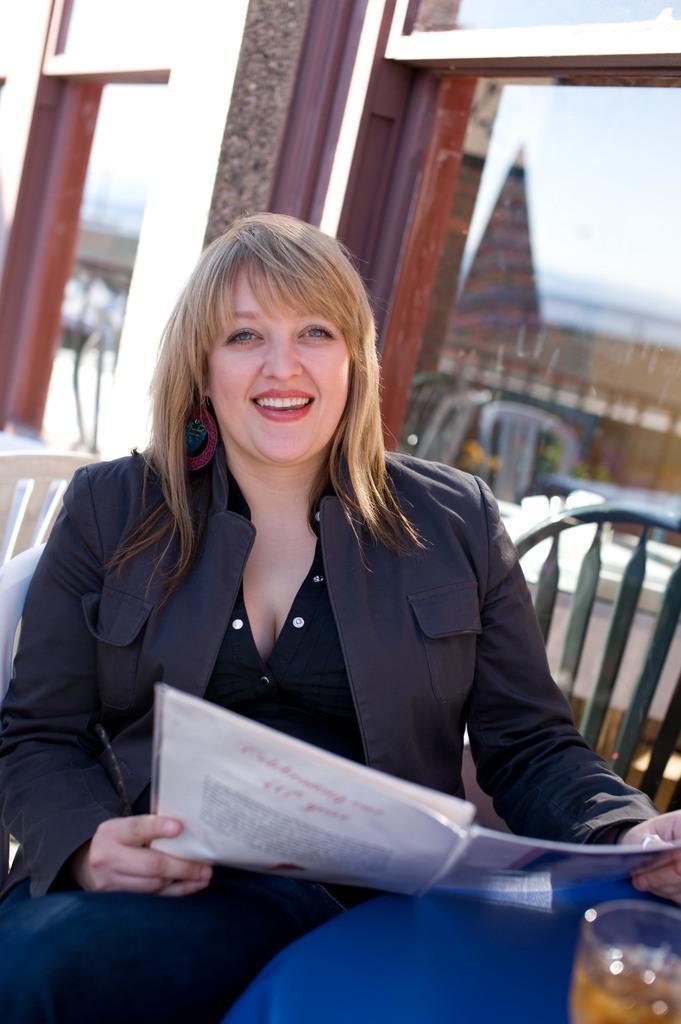Please provide a concise description of this image. In this picture I can see a woman sitting on the chair and smiling by holding a book. I can see some objects on the tables, chairs, and in the background there is a building. 